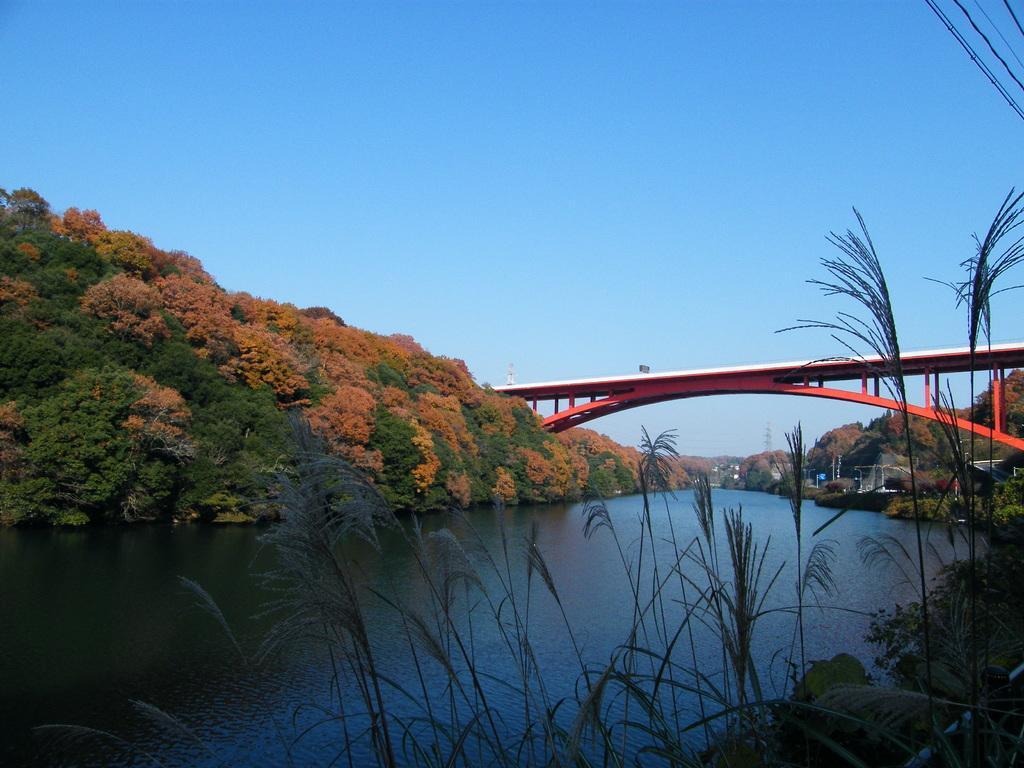In one or two sentences, can you explain what this image depicts? In this picture I can observe a river. There is a bridge over this river. I can observe some plants and trees on either sides of this river. In the background there is a sky. 